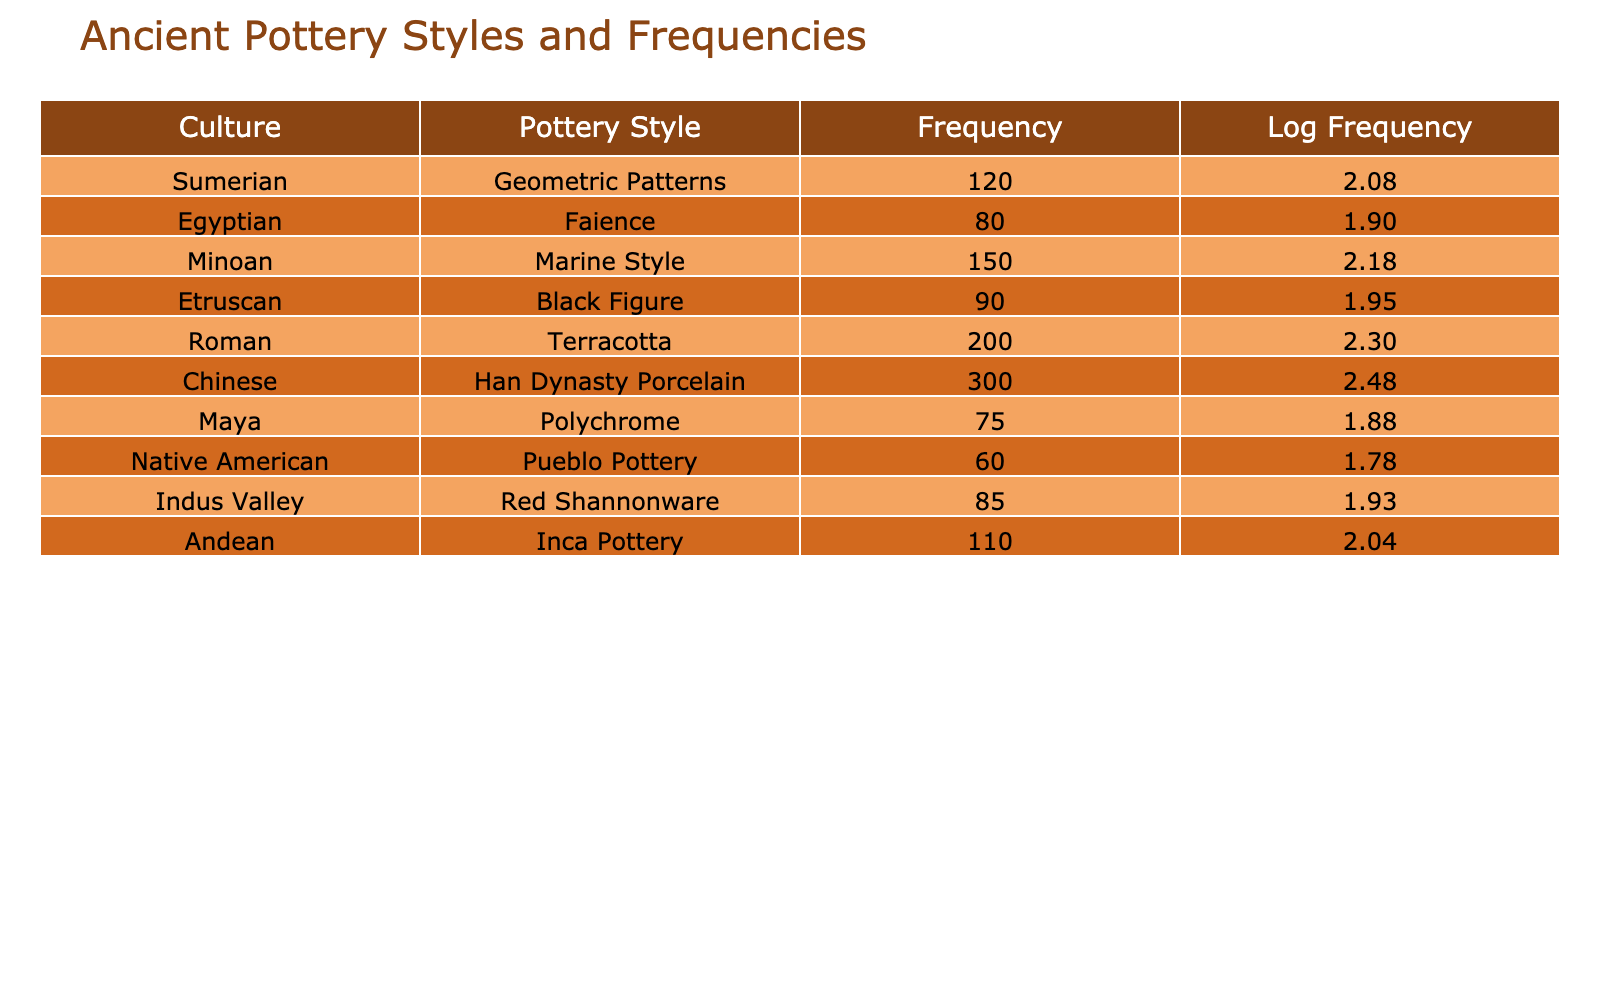What is the frequency of the most common pottery style? The table shows that the Roman Terracotta pottery style has the highest frequency at 200.
Answer: 200 Which culture has the least frequency of pottery styles mentioned? From the table, the Native American culture has the least frequency at 60 for Pueblo Pottery.
Answer: 60 What is the difference in frequency between the Chinese Han Dynasty Porcelain and the Egyptian Faience? The frequency for Han Dynasty Porcelain is 300 and for Faience is 80. The difference is 300 - 80 = 220.
Answer: 220 Are there more pottery styles from the Minoan culture than from the Andean culture? The frequency for Minoan Marine Style is 150, while for Andean Inca Pottery it is 110. Therefore, Minoan has more.
Answer: Yes What is the average frequency of pottery styles across all cultures listed in the table? First, we sum the frequencies: 120 + 80 + 150 + 90 + 200 + 300 + 75 + 60 + 85 + 110 = 1270. Then, we divide by the total number of cultures, which is 10. The average is 1270 / 10 = 127.
Answer: 127 Which pottery style has a frequency that is greater than the average? The average frequency calculated earlier is 127. The styles with frequencies greater than this are Roman Terracotta (200), Chinese Han Dynasty Porcelain (300), Minoan Marine Style (150), and Sumerian Geometric Patterns (120). Therefore, the greater ones are Terracotta, Porcelain and Marine Style.
Answer: Roman, Chinese, Minoan Is the frequency of Indus Valley pottery style greater than that of Maya? The frequency for Indus Valley Red Shannonware is 85 and for Maya Polychrome is 75. Since 85 > 75, Indus Valley has a greater frequency.
Answer: Yes What is the logarithmic value of the frequency of the Etruscan Black Figure pottery style? The table shows the frequency of the Etruscan Black Figure is 90. To find the logarithmic value, we calculate log10(90), which is approximately 1.95.
Answer: 1.95 How many pottery styles have a frequency of 100 or more? The styles that meet this criterion are Roman (200), Chinese (300), Minoan (150), Andean (110), and Sumerian (120), totaling five styles.
Answer: 5 